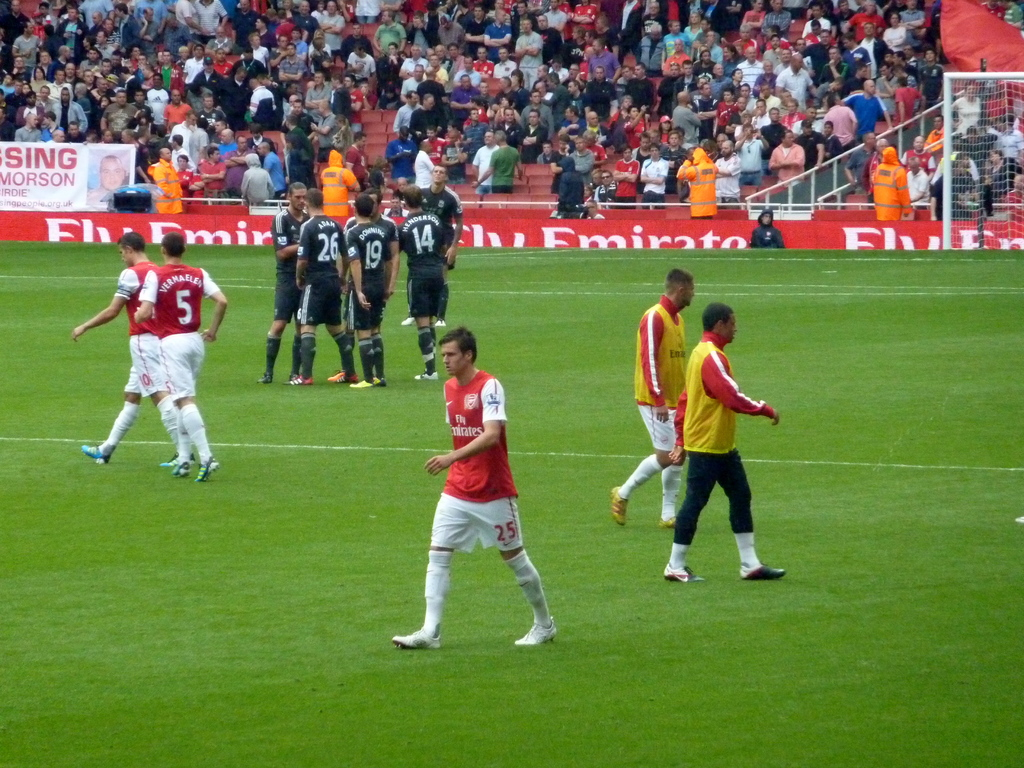Provide a one-sentence caption for the provided image. A soccer match in progress featuring players and an advertisement for 'Fly Emirates' prominently displayed at the edge of the field. 